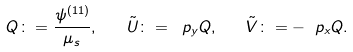<formula> <loc_0><loc_0><loc_500><loc_500>Q \colon = \frac { \psi ^ { ( 1 1 ) } } { \mu _ { s } } , \quad \tilde { U } \colon = \ p _ { y } Q , \quad \tilde { V } \colon = - \ p _ { x } Q .</formula> 